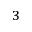<formula> <loc_0><loc_0><loc_500><loc_500>^ { 3 }</formula> 